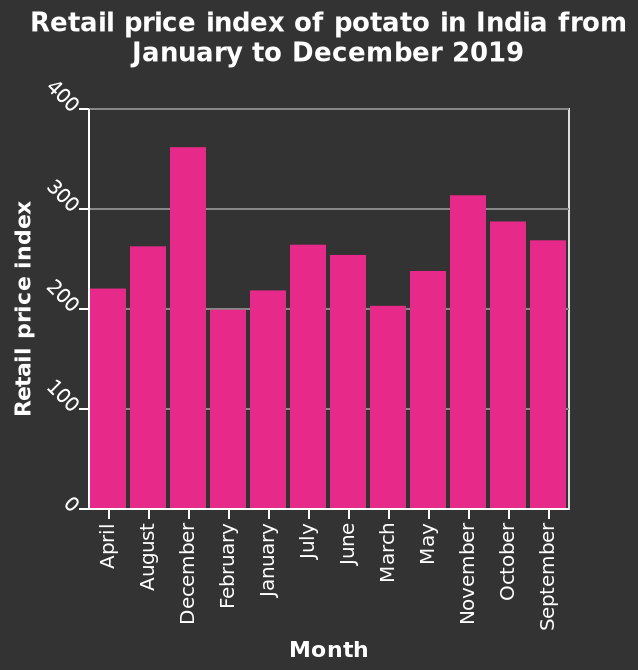<image>
When does the retail price index decrease after reaching its peak in December? It lowers again after December. please describe the details of the chart This bar graph is labeled Retail price index of potato in India from January to December 2019. A categorical scale starting with April and ending with September can be seen along the x-axis, marked Month. There is a linear scale of range 0 to 400 along the y-axis, marked Retail price index. Is this line graph labeled Retail price index of potato in India from January to December 2019? No.This bar graph is labeled Retail price index of potato in India from January to December 2019. A categorical scale starting with April and ending with September can be seen along the x-axis, marked Month. There is a linear scale of range 0 to 400 along the y-axis, marked Retail price index. 